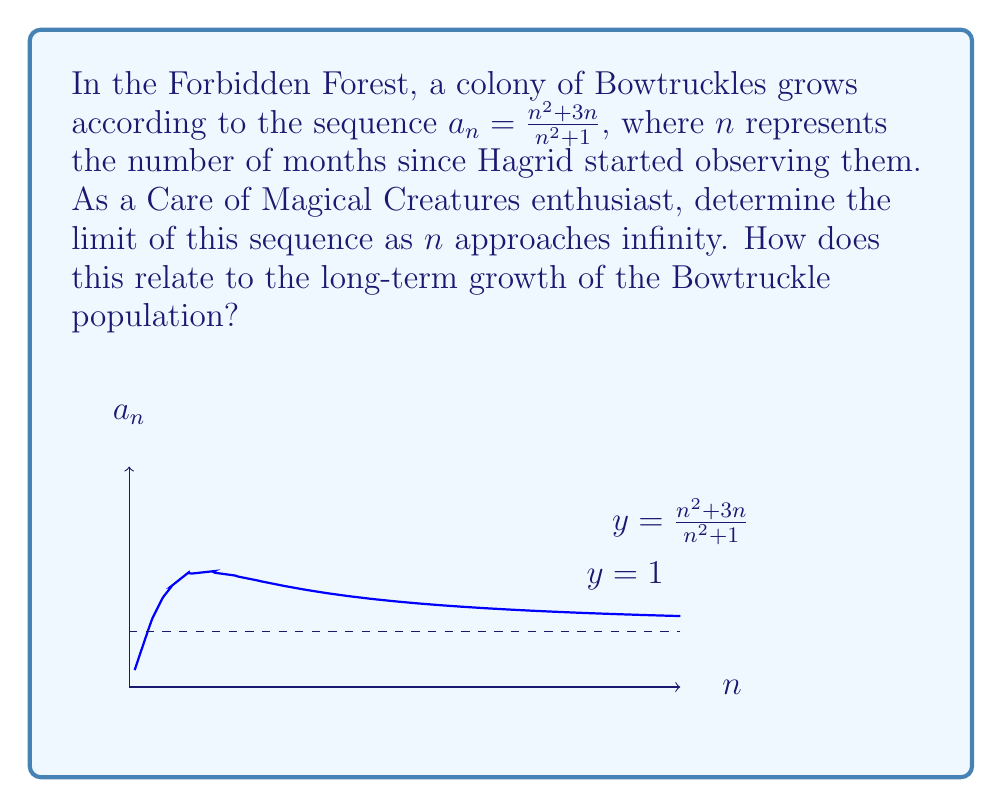Provide a solution to this math problem. To find the limit of the sequence $a_n = \frac{n^2 + 3n}{n^2 + 1}$ as $n$ approaches infinity, we can follow these steps:

1) First, let's divide both the numerator and denominator by the highest power of $n$ in the denominator, which is $n^2$:

   $$\lim_{n \to \infty} \frac{n^2 + 3n}{n^2 + 1} = \lim_{n \to \infty} \frac{\frac{n^2}{n^2} + \frac{3n}{n^2}}{\frac{n^2}{n^2} + \frac{1}{n^2}}$$

2) This simplifies to:

   $$\lim_{n \to \infty} \frac{1 + \frac{3}{n}}{1 + \frac{1}{n^2}}$$

3) As $n$ approaches infinity, $\frac{3}{n}$ and $\frac{1}{n^2}$ both approach 0:

   $$\lim_{n \to \infty} \frac{1 + 0}{1 + 0} = \frac{1}{1} = 1$$

4) Therefore, the limit of the sequence is 1.

In the context of Bowtruckle population growth, this means that as time goes on (as $n$ increases), the growth rate of the colony approaches but never quite reaches 1. This suggests that the Bowtruckle population in the Forbidden Forest will stabilize over time, reaching a steady state where the number of Bowtruckles remains relatively constant.
Answer: $1$ 